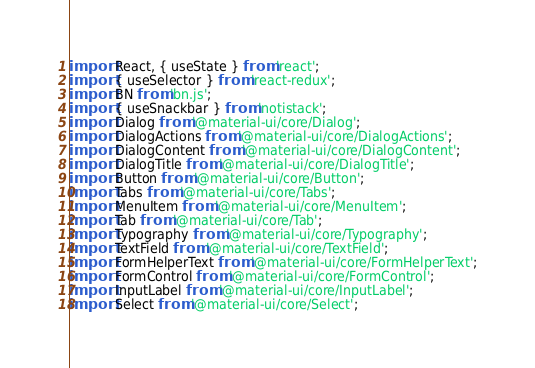Convert code to text. <code><loc_0><loc_0><loc_500><loc_500><_TypeScript_>import React, { useState } from 'react';
import { useSelector } from 'react-redux';
import BN from 'bn.js';
import { useSnackbar } from 'notistack';
import Dialog from '@material-ui/core/Dialog';
import DialogActions from '@material-ui/core/DialogActions';
import DialogContent from '@material-ui/core/DialogContent';
import DialogTitle from '@material-ui/core/DialogTitle';
import Button from '@material-ui/core/Button';
import Tabs from '@material-ui/core/Tabs';
import MenuItem from '@material-ui/core/MenuItem';
import Tab from '@material-ui/core/Tab';
import Typography from '@material-ui/core/Typography';
import TextField from '@material-ui/core/TextField';
import FormHelperText from '@material-ui/core/FormHelperText';
import FormControl from '@material-ui/core/FormControl';
import InputLabel from '@material-ui/core/InputLabel';
import Select from '@material-ui/core/Select';</code> 